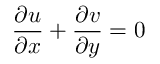<formula> <loc_0><loc_0><loc_500><loc_500>\frac { \partial u } { \partial x } + \frac { \partial v } { \partial y } = 0</formula> 